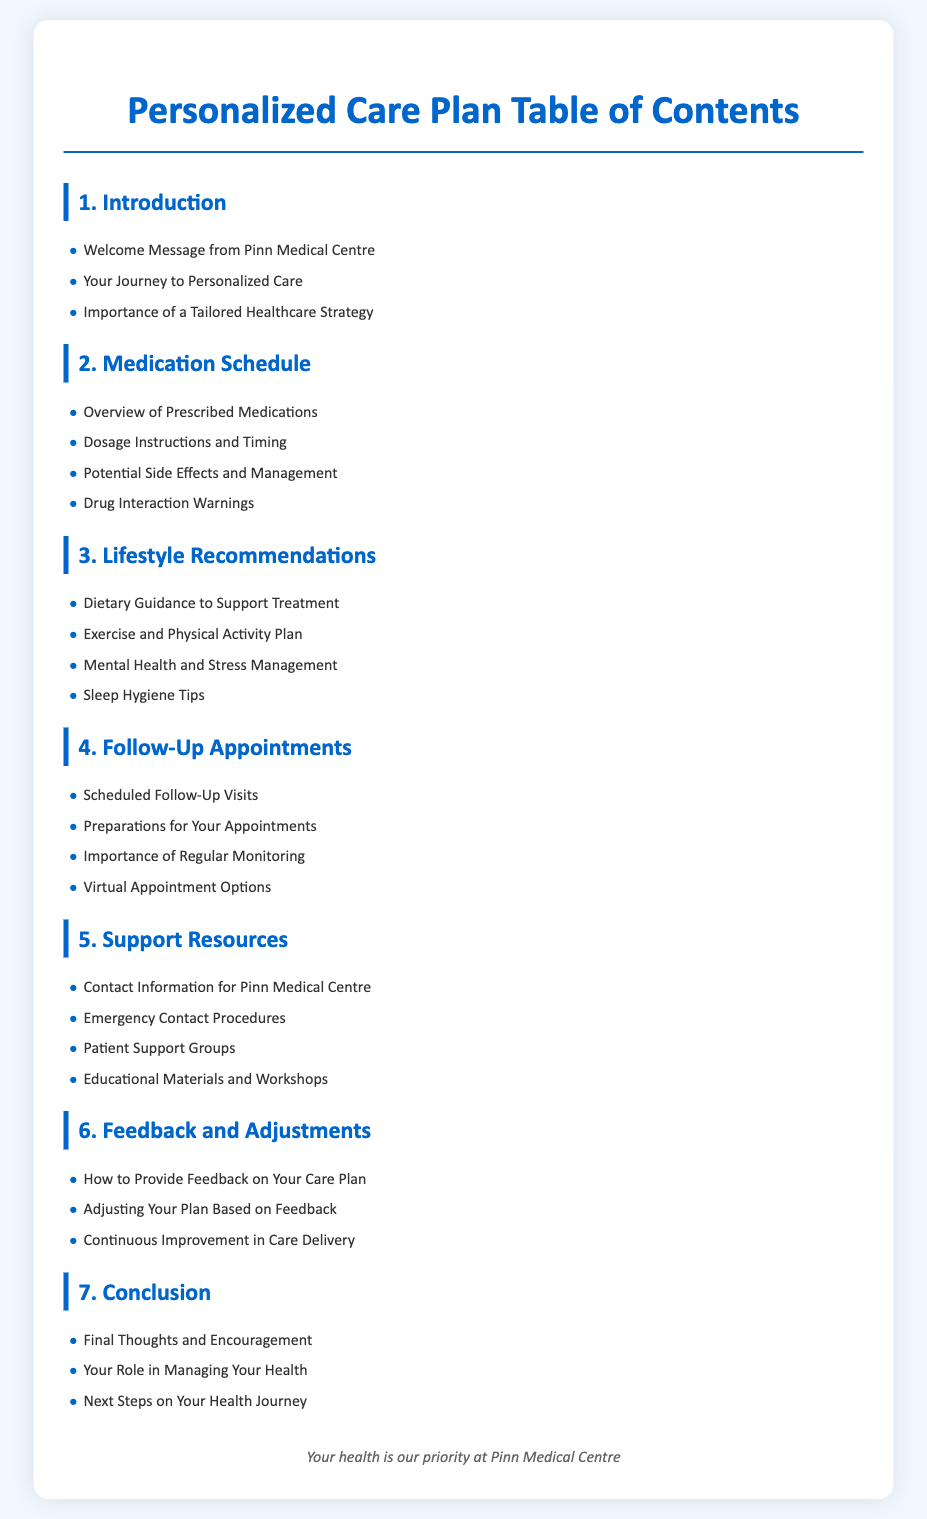what is the title of the document? The title of the document is specified in the HTML's title tag.
Answer: Personalized Care Plan - Pinn Medical Centre how many sections are in the table of contents? The number of sections can be counted from the listed headings in the document.
Answer: 7 what information is provided in the introduction section? The introduction section lists specific topics that are covered, which include a welcome message and the importance of personalized care.
Answer: Welcome Message from Pinn Medical Centre, Your Journey to Personalized Care, Importance of a Tailored Healthcare Strategy what is the focus of the lifestyle recommendations section? This section outlines various aspects of lifestyle changes that can support treatment, including diet and exercise.
Answer: Dietary Guidance to Support Treatment, Exercise and Physical Activity Plan, Mental Health and Stress Management, Sleep Hygiene Tips what is mentioned in the feedback and adjustments section? The feedback section outlines how patients can communicate their experiences and adjustments to their care plans.
Answer: How to Provide Feedback on Your Care Plan, Adjusting Your Plan Based on Feedback, Continuous Improvement in Care Delivery what type of resources does the support resources section cover? This section provides essential contact information and support options available to patients.
Answer: Contact Information for Pinn Medical Centre, Emergency Contact Procedures, Patient Support Groups, Educational Materials and Workshops what is stated as the importance of follow-up appointments? This section emphasizes the need for monitoring health status through scheduled visits.
Answer: Importance of Regular Monitoring 